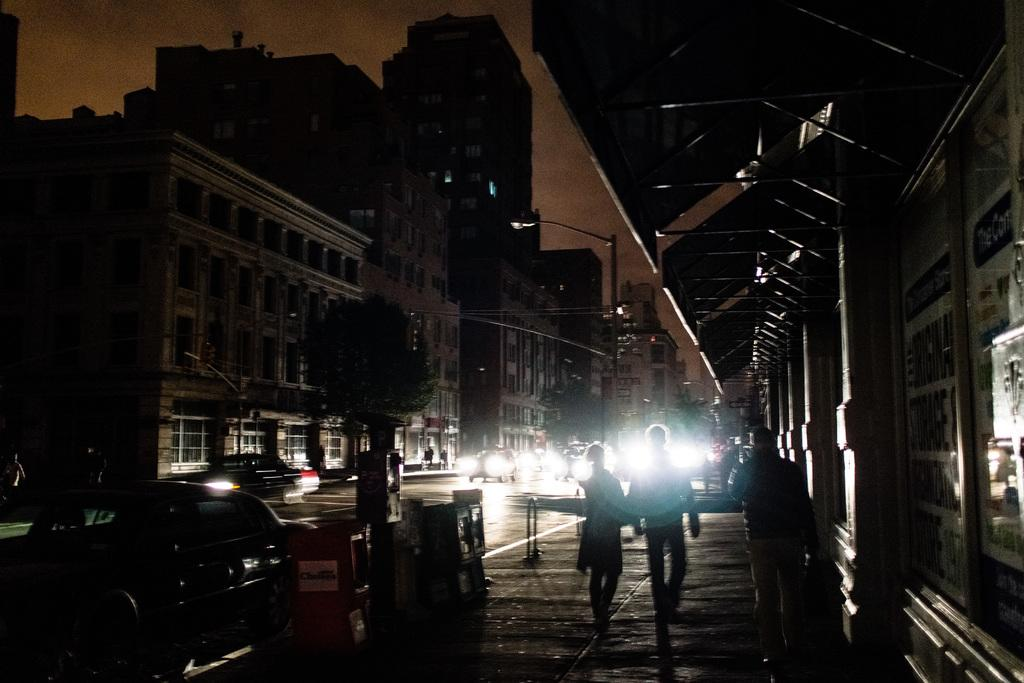What are the people in the image doing? The people in the image are walking on a walkway. What else can be seen in the image besides the people? There are vehicles on a road and poles visible in the image. What type of structures are present on either side of the road? There are buildings on either side of the road in the image. What type of metal is used to make the underwear worn by the people in the image? There is no information about the type of underwear worn by the people in the image, nor is there any mention of metal being used in the image. 